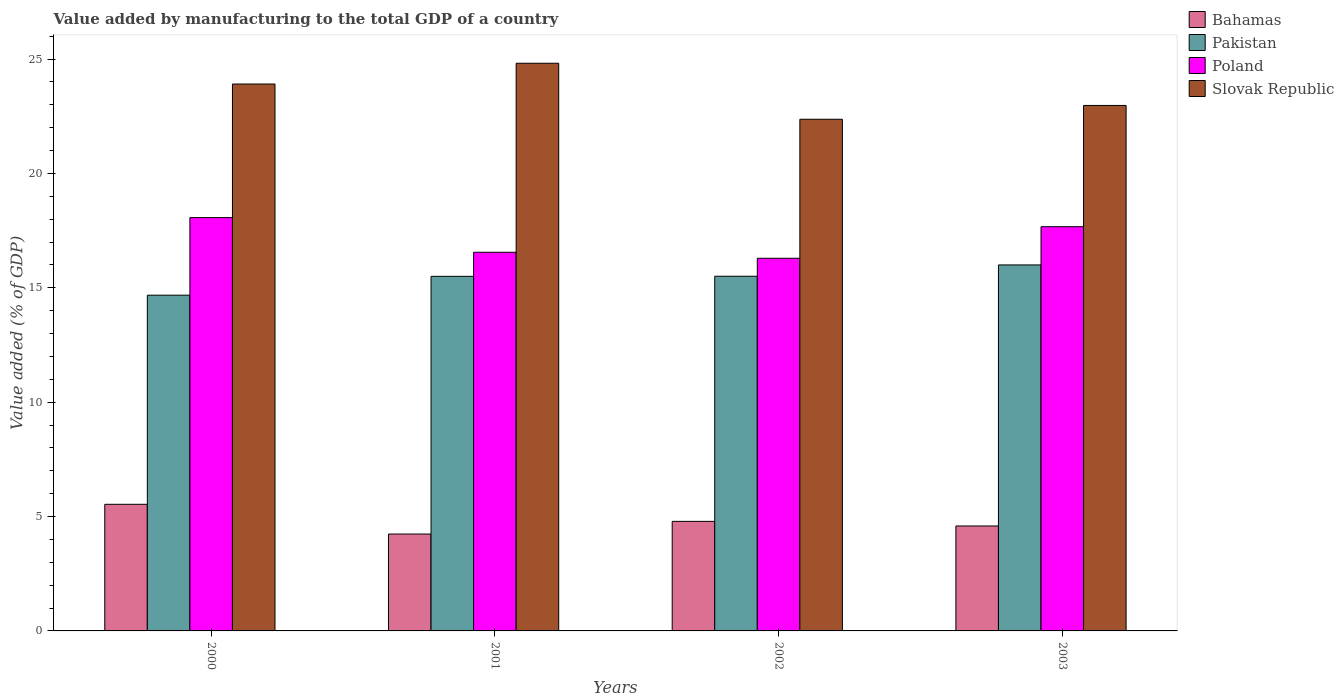How many bars are there on the 4th tick from the right?
Offer a terse response. 4. What is the label of the 4th group of bars from the left?
Offer a very short reply. 2003. What is the value added by manufacturing to the total GDP in Bahamas in 2001?
Ensure brevity in your answer.  4.24. Across all years, what is the maximum value added by manufacturing to the total GDP in Slovak Republic?
Ensure brevity in your answer.  24.82. Across all years, what is the minimum value added by manufacturing to the total GDP in Pakistan?
Ensure brevity in your answer.  14.68. In which year was the value added by manufacturing to the total GDP in Slovak Republic maximum?
Provide a short and direct response. 2001. What is the total value added by manufacturing to the total GDP in Pakistan in the graph?
Provide a short and direct response. 61.68. What is the difference between the value added by manufacturing to the total GDP in Bahamas in 2000 and that in 2003?
Provide a succinct answer. 0.95. What is the difference between the value added by manufacturing to the total GDP in Poland in 2000 and the value added by manufacturing to the total GDP in Bahamas in 2003?
Provide a succinct answer. 13.48. What is the average value added by manufacturing to the total GDP in Pakistan per year?
Provide a succinct answer. 15.42. In the year 2000, what is the difference between the value added by manufacturing to the total GDP in Poland and value added by manufacturing to the total GDP in Bahamas?
Your answer should be very brief. 12.53. What is the ratio of the value added by manufacturing to the total GDP in Pakistan in 2000 to that in 2001?
Give a very brief answer. 0.95. Is the difference between the value added by manufacturing to the total GDP in Poland in 2000 and 2002 greater than the difference between the value added by manufacturing to the total GDP in Bahamas in 2000 and 2002?
Offer a very short reply. Yes. What is the difference between the highest and the second highest value added by manufacturing to the total GDP in Bahamas?
Give a very brief answer. 0.75. What is the difference between the highest and the lowest value added by manufacturing to the total GDP in Bahamas?
Ensure brevity in your answer.  1.3. Is it the case that in every year, the sum of the value added by manufacturing to the total GDP in Slovak Republic and value added by manufacturing to the total GDP in Bahamas is greater than the sum of value added by manufacturing to the total GDP in Poland and value added by manufacturing to the total GDP in Pakistan?
Make the answer very short. Yes. What does the 1st bar from the right in 2003 represents?
Your answer should be very brief. Slovak Republic. Is it the case that in every year, the sum of the value added by manufacturing to the total GDP in Poland and value added by manufacturing to the total GDP in Bahamas is greater than the value added by manufacturing to the total GDP in Pakistan?
Give a very brief answer. Yes. What is the difference between two consecutive major ticks on the Y-axis?
Ensure brevity in your answer.  5. Are the values on the major ticks of Y-axis written in scientific E-notation?
Give a very brief answer. No. Does the graph contain grids?
Give a very brief answer. No. How many legend labels are there?
Your answer should be compact. 4. How are the legend labels stacked?
Keep it short and to the point. Vertical. What is the title of the graph?
Your answer should be compact. Value added by manufacturing to the total GDP of a country. What is the label or title of the X-axis?
Your answer should be very brief. Years. What is the label or title of the Y-axis?
Offer a very short reply. Value added (% of GDP). What is the Value added (% of GDP) of Bahamas in 2000?
Give a very brief answer. 5.54. What is the Value added (% of GDP) in Pakistan in 2000?
Provide a succinct answer. 14.68. What is the Value added (% of GDP) of Poland in 2000?
Give a very brief answer. 18.07. What is the Value added (% of GDP) in Slovak Republic in 2000?
Give a very brief answer. 23.91. What is the Value added (% of GDP) of Bahamas in 2001?
Your response must be concise. 4.24. What is the Value added (% of GDP) in Pakistan in 2001?
Keep it short and to the point. 15.5. What is the Value added (% of GDP) of Poland in 2001?
Offer a terse response. 16.55. What is the Value added (% of GDP) in Slovak Republic in 2001?
Your answer should be very brief. 24.82. What is the Value added (% of GDP) in Bahamas in 2002?
Offer a very short reply. 4.79. What is the Value added (% of GDP) of Pakistan in 2002?
Your response must be concise. 15.5. What is the Value added (% of GDP) of Poland in 2002?
Your response must be concise. 16.29. What is the Value added (% of GDP) in Slovak Republic in 2002?
Provide a succinct answer. 22.37. What is the Value added (% of GDP) in Bahamas in 2003?
Provide a short and direct response. 4.59. What is the Value added (% of GDP) of Pakistan in 2003?
Keep it short and to the point. 16. What is the Value added (% of GDP) in Poland in 2003?
Give a very brief answer. 17.67. What is the Value added (% of GDP) in Slovak Republic in 2003?
Offer a terse response. 22.97. Across all years, what is the maximum Value added (% of GDP) of Bahamas?
Provide a short and direct response. 5.54. Across all years, what is the maximum Value added (% of GDP) in Pakistan?
Keep it short and to the point. 16. Across all years, what is the maximum Value added (% of GDP) of Poland?
Your answer should be compact. 18.07. Across all years, what is the maximum Value added (% of GDP) in Slovak Republic?
Give a very brief answer. 24.82. Across all years, what is the minimum Value added (% of GDP) of Bahamas?
Ensure brevity in your answer.  4.24. Across all years, what is the minimum Value added (% of GDP) in Pakistan?
Provide a succinct answer. 14.68. Across all years, what is the minimum Value added (% of GDP) of Poland?
Give a very brief answer. 16.29. Across all years, what is the minimum Value added (% of GDP) of Slovak Republic?
Provide a short and direct response. 22.37. What is the total Value added (% of GDP) in Bahamas in the graph?
Make the answer very short. 19.15. What is the total Value added (% of GDP) in Pakistan in the graph?
Your response must be concise. 61.68. What is the total Value added (% of GDP) of Poland in the graph?
Your answer should be compact. 68.58. What is the total Value added (% of GDP) of Slovak Republic in the graph?
Ensure brevity in your answer.  94.06. What is the difference between the Value added (% of GDP) in Bahamas in 2000 and that in 2001?
Offer a terse response. 1.3. What is the difference between the Value added (% of GDP) in Pakistan in 2000 and that in 2001?
Make the answer very short. -0.82. What is the difference between the Value added (% of GDP) in Poland in 2000 and that in 2001?
Provide a succinct answer. 1.52. What is the difference between the Value added (% of GDP) in Slovak Republic in 2000 and that in 2001?
Provide a succinct answer. -0.91. What is the difference between the Value added (% of GDP) of Bahamas in 2000 and that in 2002?
Offer a very short reply. 0.75. What is the difference between the Value added (% of GDP) of Pakistan in 2000 and that in 2002?
Make the answer very short. -0.83. What is the difference between the Value added (% of GDP) of Poland in 2000 and that in 2002?
Make the answer very short. 1.78. What is the difference between the Value added (% of GDP) of Slovak Republic in 2000 and that in 2002?
Your answer should be very brief. 1.54. What is the difference between the Value added (% of GDP) in Bahamas in 2000 and that in 2003?
Offer a very short reply. 0.95. What is the difference between the Value added (% of GDP) of Pakistan in 2000 and that in 2003?
Your answer should be compact. -1.32. What is the difference between the Value added (% of GDP) in Poland in 2000 and that in 2003?
Offer a terse response. 0.4. What is the difference between the Value added (% of GDP) in Slovak Republic in 2000 and that in 2003?
Make the answer very short. 0.94. What is the difference between the Value added (% of GDP) of Bahamas in 2001 and that in 2002?
Provide a short and direct response. -0.55. What is the difference between the Value added (% of GDP) of Pakistan in 2001 and that in 2002?
Provide a short and direct response. -0. What is the difference between the Value added (% of GDP) in Poland in 2001 and that in 2002?
Give a very brief answer. 0.26. What is the difference between the Value added (% of GDP) of Slovak Republic in 2001 and that in 2002?
Make the answer very short. 2.45. What is the difference between the Value added (% of GDP) in Bahamas in 2001 and that in 2003?
Ensure brevity in your answer.  -0.35. What is the difference between the Value added (% of GDP) in Pakistan in 2001 and that in 2003?
Make the answer very short. -0.5. What is the difference between the Value added (% of GDP) of Poland in 2001 and that in 2003?
Ensure brevity in your answer.  -1.12. What is the difference between the Value added (% of GDP) of Slovak Republic in 2001 and that in 2003?
Your response must be concise. 1.84. What is the difference between the Value added (% of GDP) of Bahamas in 2002 and that in 2003?
Provide a succinct answer. 0.2. What is the difference between the Value added (% of GDP) in Pakistan in 2002 and that in 2003?
Provide a succinct answer. -0.49. What is the difference between the Value added (% of GDP) of Poland in 2002 and that in 2003?
Keep it short and to the point. -1.38. What is the difference between the Value added (% of GDP) of Slovak Republic in 2002 and that in 2003?
Your response must be concise. -0.6. What is the difference between the Value added (% of GDP) in Bahamas in 2000 and the Value added (% of GDP) in Pakistan in 2001?
Your answer should be compact. -9.97. What is the difference between the Value added (% of GDP) in Bahamas in 2000 and the Value added (% of GDP) in Poland in 2001?
Make the answer very short. -11.02. What is the difference between the Value added (% of GDP) in Bahamas in 2000 and the Value added (% of GDP) in Slovak Republic in 2001?
Make the answer very short. -19.28. What is the difference between the Value added (% of GDP) of Pakistan in 2000 and the Value added (% of GDP) of Poland in 2001?
Your response must be concise. -1.88. What is the difference between the Value added (% of GDP) of Pakistan in 2000 and the Value added (% of GDP) of Slovak Republic in 2001?
Make the answer very short. -10.14. What is the difference between the Value added (% of GDP) of Poland in 2000 and the Value added (% of GDP) of Slovak Republic in 2001?
Ensure brevity in your answer.  -6.75. What is the difference between the Value added (% of GDP) of Bahamas in 2000 and the Value added (% of GDP) of Pakistan in 2002?
Give a very brief answer. -9.97. What is the difference between the Value added (% of GDP) in Bahamas in 2000 and the Value added (% of GDP) in Poland in 2002?
Offer a very short reply. -10.76. What is the difference between the Value added (% of GDP) of Bahamas in 2000 and the Value added (% of GDP) of Slovak Republic in 2002?
Provide a short and direct response. -16.83. What is the difference between the Value added (% of GDP) in Pakistan in 2000 and the Value added (% of GDP) in Poland in 2002?
Offer a very short reply. -1.61. What is the difference between the Value added (% of GDP) of Pakistan in 2000 and the Value added (% of GDP) of Slovak Republic in 2002?
Provide a succinct answer. -7.69. What is the difference between the Value added (% of GDP) of Poland in 2000 and the Value added (% of GDP) of Slovak Republic in 2002?
Keep it short and to the point. -4.3. What is the difference between the Value added (% of GDP) of Bahamas in 2000 and the Value added (% of GDP) of Pakistan in 2003?
Your answer should be very brief. -10.46. What is the difference between the Value added (% of GDP) in Bahamas in 2000 and the Value added (% of GDP) in Poland in 2003?
Provide a succinct answer. -12.14. What is the difference between the Value added (% of GDP) of Bahamas in 2000 and the Value added (% of GDP) of Slovak Republic in 2003?
Make the answer very short. -17.44. What is the difference between the Value added (% of GDP) in Pakistan in 2000 and the Value added (% of GDP) in Poland in 2003?
Offer a very short reply. -2.99. What is the difference between the Value added (% of GDP) in Pakistan in 2000 and the Value added (% of GDP) in Slovak Republic in 2003?
Ensure brevity in your answer.  -8.29. What is the difference between the Value added (% of GDP) in Poland in 2000 and the Value added (% of GDP) in Slovak Republic in 2003?
Make the answer very short. -4.9. What is the difference between the Value added (% of GDP) in Bahamas in 2001 and the Value added (% of GDP) in Pakistan in 2002?
Your answer should be compact. -11.27. What is the difference between the Value added (% of GDP) of Bahamas in 2001 and the Value added (% of GDP) of Poland in 2002?
Ensure brevity in your answer.  -12.06. What is the difference between the Value added (% of GDP) in Bahamas in 2001 and the Value added (% of GDP) in Slovak Republic in 2002?
Keep it short and to the point. -18.13. What is the difference between the Value added (% of GDP) in Pakistan in 2001 and the Value added (% of GDP) in Poland in 2002?
Make the answer very short. -0.79. What is the difference between the Value added (% of GDP) of Pakistan in 2001 and the Value added (% of GDP) of Slovak Republic in 2002?
Provide a succinct answer. -6.87. What is the difference between the Value added (% of GDP) in Poland in 2001 and the Value added (% of GDP) in Slovak Republic in 2002?
Ensure brevity in your answer.  -5.81. What is the difference between the Value added (% of GDP) of Bahamas in 2001 and the Value added (% of GDP) of Pakistan in 2003?
Your answer should be very brief. -11.76. What is the difference between the Value added (% of GDP) in Bahamas in 2001 and the Value added (% of GDP) in Poland in 2003?
Offer a terse response. -13.44. What is the difference between the Value added (% of GDP) of Bahamas in 2001 and the Value added (% of GDP) of Slovak Republic in 2003?
Offer a very short reply. -18.74. What is the difference between the Value added (% of GDP) of Pakistan in 2001 and the Value added (% of GDP) of Poland in 2003?
Your answer should be compact. -2.17. What is the difference between the Value added (% of GDP) in Pakistan in 2001 and the Value added (% of GDP) in Slovak Republic in 2003?
Ensure brevity in your answer.  -7.47. What is the difference between the Value added (% of GDP) in Poland in 2001 and the Value added (% of GDP) in Slovak Republic in 2003?
Make the answer very short. -6.42. What is the difference between the Value added (% of GDP) in Bahamas in 2002 and the Value added (% of GDP) in Pakistan in 2003?
Provide a succinct answer. -11.21. What is the difference between the Value added (% of GDP) of Bahamas in 2002 and the Value added (% of GDP) of Poland in 2003?
Your answer should be compact. -12.88. What is the difference between the Value added (% of GDP) of Bahamas in 2002 and the Value added (% of GDP) of Slovak Republic in 2003?
Your response must be concise. -18.18. What is the difference between the Value added (% of GDP) of Pakistan in 2002 and the Value added (% of GDP) of Poland in 2003?
Make the answer very short. -2.17. What is the difference between the Value added (% of GDP) of Pakistan in 2002 and the Value added (% of GDP) of Slovak Republic in 2003?
Your answer should be compact. -7.47. What is the difference between the Value added (% of GDP) of Poland in 2002 and the Value added (% of GDP) of Slovak Republic in 2003?
Your response must be concise. -6.68. What is the average Value added (% of GDP) in Bahamas per year?
Ensure brevity in your answer.  4.79. What is the average Value added (% of GDP) in Pakistan per year?
Keep it short and to the point. 15.42. What is the average Value added (% of GDP) in Poland per year?
Your response must be concise. 17.15. What is the average Value added (% of GDP) in Slovak Republic per year?
Provide a short and direct response. 23.52. In the year 2000, what is the difference between the Value added (% of GDP) of Bahamas and Value added (% of GDP) of Pakistan?
Make the answer very short. -9.14. In the year 2000, what is the difference between the Value added (% of GDP) of Bahamas and Value added (% of GDP) of Poland?
Give a very brief answer. -12.53. In the year 2000, what is the difference between the Value added (% of GDP) of Bahamas and Value added (% of GDP) of Slovak Republic?
Your answer should be compact. -18.37. In the year 2000, what is the difference between the Value added (% of GDP) of Pakistan and Value added (% of GDP) of Poland?
Make the answer very short. -3.39. In the year 2000, what is the difference between the Value added (% of GDP) of Pakistan and Value added (% of GDP) of Slovak Republic?
Ensure brevity in your answer.  -9.23. In the year 2000, what is the difference between the Value added (% of GDP) of Poland and Value added (% of GDP) of Slovak Republic?
Make the answer very short. -5.84. In the year 2001, what is the difference between the Value added (% of GDP) in Bahamas and Value added (% of GDP) in Pakistan?
Provide a succinct answer. -11.27. In the year 2001, what is the difference between the Value added (% of GDP) in Bahamas and Value added (% of GDP) in Poland?
Provide a short and direct response. -12.32. In the year 2001, what is the difference between the Value added (% of GDP) of Bahamas and Value added (% of GDP) of Slovak Republic?
Offer a very short reply. -20.58. In the year 2001, what is the difference between the Value added (% of GDP) in Pakistan and Value added (% of GDP) in Poland?
Your answer should be compact. -1.05. In the year 2001, what is the difference between the Value added (% of GDP) in Pakistan and Value added (% of GDP) in Slovak Republic?
Ensure brevity in your answer.  -9.31. In the year 2001, what is the difference between the Value added (% of GDP) of Poland and Value added (% of GDP) of Slovak Republic?
Offer a very short reply. -8.26. In the year 2002, what is the difference between the Value added (% of GDP) of Bahamas and Value added (% of GDP) of Pakistan?
Offer a terse response. -10.72. In the year 2002, what is the difference between the Value added (% of GDP) in Bahamas and Value added (% of GDP) in Poland?
Offer a terse response. -11.5. In the year 2002, what is the difference between the Value added (% of GDP) of Bahamas and Value added (% of GDP) of Slovak Republic?
Give a very brief answer. -17.58. In the year 2002, what is the difference between the Value added (% of GDP) of Pakistan and Value added (% of GDP) of Poland?
Your answer should be very brief. -0.79. In the year 2002, what is the difference between the Value added (% of GDP) in Pakistan and Value added (% of GDP) in Slovak Republic?
Make the answer very short. -6.86. In the year 2002, what is the difference between the Value added (% of GDP) of Poland and Value added (% of GDP) of Slovak Republic?
Make the answer very short. -6.08. In the year 2003, what is the difference between the Value added (% of GDP) in Bahamas and Value added (% of GDP) in Pakistan?
Provide a succinct answer. -11.41. In the year 2003, what is the difference between the Value added (% of GDP) of Bahamas and Value added (% of GDP) of Poland?
Your answer should be very brief. -13.08. In the year 2003, what is the difference between the Value added (% of GDP) in Bahamas and Value added (% of GDP) in Slovak Republic?
Your answer should be very brief. -18.38. In the year 2003, what is the difference between the Value added (% of GDP) in Pakistan and Value added (% of GDP) in Poland?
Give a very brief answer. -1.67. In the year 2003, what is the difference between the Value added (% of GDP) of Pakistan and Value added (% of GDP) of Slovak Republic?
Your answer should be very brief. -6.97. In the year 2003, what is the difference between the Value added (% of GDP) in Poland and Value added (% of GDP) in Slovak Republic?
Give a very brief answer. -5.3. What is the ratio of the Value added (% of GDP) of Bahamas in 2000 to that in 2001?
Your answer should be compact. 1.31. What is the ratio of the Value added (% of GDP) of Pakistan in 2000 to that in 2001?
Ensure brevity in your answer.  0.95. What is the ratio of the Value added (% of GDP) of Poland in 2000 to that in 2001?
Provide a short and direct response. 1.09. What is the ratio of the Value added (% of GDP) of Slovak Republic in 2000 to that in 2001?
Offer a very short reply. 0.96. What is the ratio of the Value added (% of GDP) in Bahamas in 2000 to that in 2002?
Make the answer very short. 1.16. What is the ratio of the Value added (% of GDP) of Pakistan in 2000 to that in 2002?
Your response must be concise. 0.95. What is the ratio of the Value added (% of GDP) in Poland in 2000 to that in 2002?
Your response must be concise. 1.11. What is the ratio of the Value added (% of GDP) in Slovak Republic in 2000 to that in 2002?
Provide a short and direct response. 1.07. What is the ratio of the Value added (% of GDP) of Bahamas in 2000 to that in 2003?
Provide a succinct answer. 1.21. What is the ratio of the Value added (% of GDP) in Pakistan in 2000 to that in 2003?
Your answer should be compact. 0.92. What is the ratio of the Value added (% of GDP) in Poland in 2000 to that in 2003?
Give a very brief answer. 1.02. What is the ratio of the Value added (% of GDP) of Slovak Republic in 2000 to that in 2003?
Offer a terse response. 1.04. What is the ratio of the Value added (% of GDP) in Bahamas in 2001 to that in 2002?
Make the answer very short. 0.88. What is the ratio of the Value added (% of GDP) of Poland in 2001 to that in 2002?
Your response must be concise. 1.02. What is the ratio of the Value added (% of GDP) in Slovak Republic in 2001 to that in 2002?
Offer a very short reply. 1.11. What is the ratio of the Value added (% of GDP) of Bahamas in 2001 to that in 2003?
Make the answer very short. 0.92. What is the ratio of the Value added (% of GDP) of Pakistan in 2001 to that in 2003?
Make the answer very short. 0.97. What is the ratio of the Value added (% of GDP) of Poland in 2001 to that in 2003?
Give a very brief answer. 0.94. What is the ratio of the Value added (% of GDP) in Slovak Republic in 2001 to that in 2003?
Your response must be concise. 1.08. What is the ratio of the Value added (% of GDP) in Bahamas in 2002 to that in 2003?
Offer a very short reply. 1.04. What is the ratio of the Value added (% of GDP) of Pakistan in 2002 to that in 2003?
Give a very brief answer. 0.97. What is the ratio of the Value added (% of GDP) of Poland in 2002 to that in 2003?
Keep it short and to the point. 0.92. What is the ratio of the Value added (% of GDP) in Slovak Republic in 2002 to that in 2003?
Your answer should be compact. 0.97. What is the difference between the highest and the second highest Value added (% of GDP) of Bahamas?
Your answer should be compact. 0.75. What is the difference between the highest and the second highest Value added (% of GDP) of Pakistan?
Offer a very short reply. 0.49. What is the difference between the highest and the second highest Value added (% of GDP) of Poland?
Offer a terse response. 0.4. What is the difference between the highest and the second highest Value added (% of GDP) in Slovak Republic?
Make the answer very short. 0.91. What is the difference between the highest and the lowest Value added (% of GDP) in Bahamas?
Offer a very short reply. 1.3. What is the difference between the highest and the lowest Value added (% of GDP) in Pakistan?
Provide a succinct answer. 1.32. What is the difference between the highest and the lowest Value added (% of GDP) of Poland?
Ensure brevity in your answer.  1.78. What is the difference between the highest and the lowest Value added (% of GDP) in Slovak Republic?
Provide a succinct answer. 2.45. 